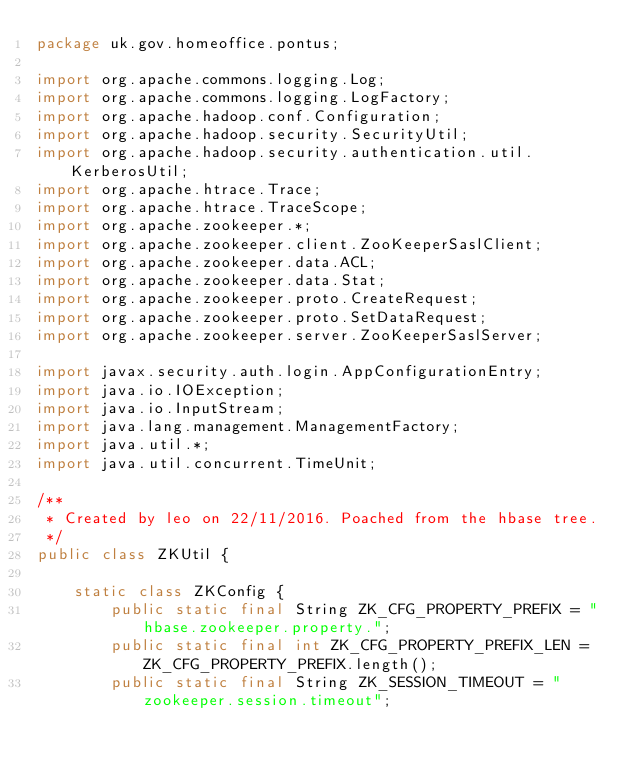Convert code to text. <code><loc_0><loc_0><loc_500><loc_500><_Java_>package uk.gov.homeoffice.pontus;

import org.apache.commons.logging.Log;
import org.apache.commons.logging.LogFactory;
import org.apache.hadoop.conf.Configuration;
import org.apache.hadoop.security.SecurityUtil;
import org.apache.hadoop.security.authentication.util.KerberosUtil;
import org.apache.htrace.Trace;
import org.apache.htrace.TraceScope;
import org.apache.zookeeper.*;
import org.apache.zookeeper.client.ZooKeeperSaslClient;
import org.apache.zookeeper.data.ACL;
import org.apache.zookeeper.data.Stat;
import org.apache.zookeeper.proto.CreateRequest;
import org.apache.zookeeper.proto.SetDataRequest;
import org.apache.zookeeper.server.ZooKeeperSaslServer;

import javax.security.auth.login.AppConfigurationEntry;
import java.io.IOException;
import java.io.InputStream;
import java.lang.management.ManagementFactory;
import java.util.*;
import java.util.concurrent.TimeUnit;

/**
 * Created by leo on 22/11/2016. Poached from the hbase tree.
 */
public class ZKUtil {

    static class ZKConfig {
        public static final String ZK_CFG_PROPERTY_PREFIX = "hbase.zookeeper.property.";
        public static final int ZK_CFG_PROPERTY_PREFIX_LEN = ZK_CFG_PROPERTY_PREFIX.length();
        public static final String ZK_SESSION_TIMEOUT = "zookeeper.session.timeout";</code> 